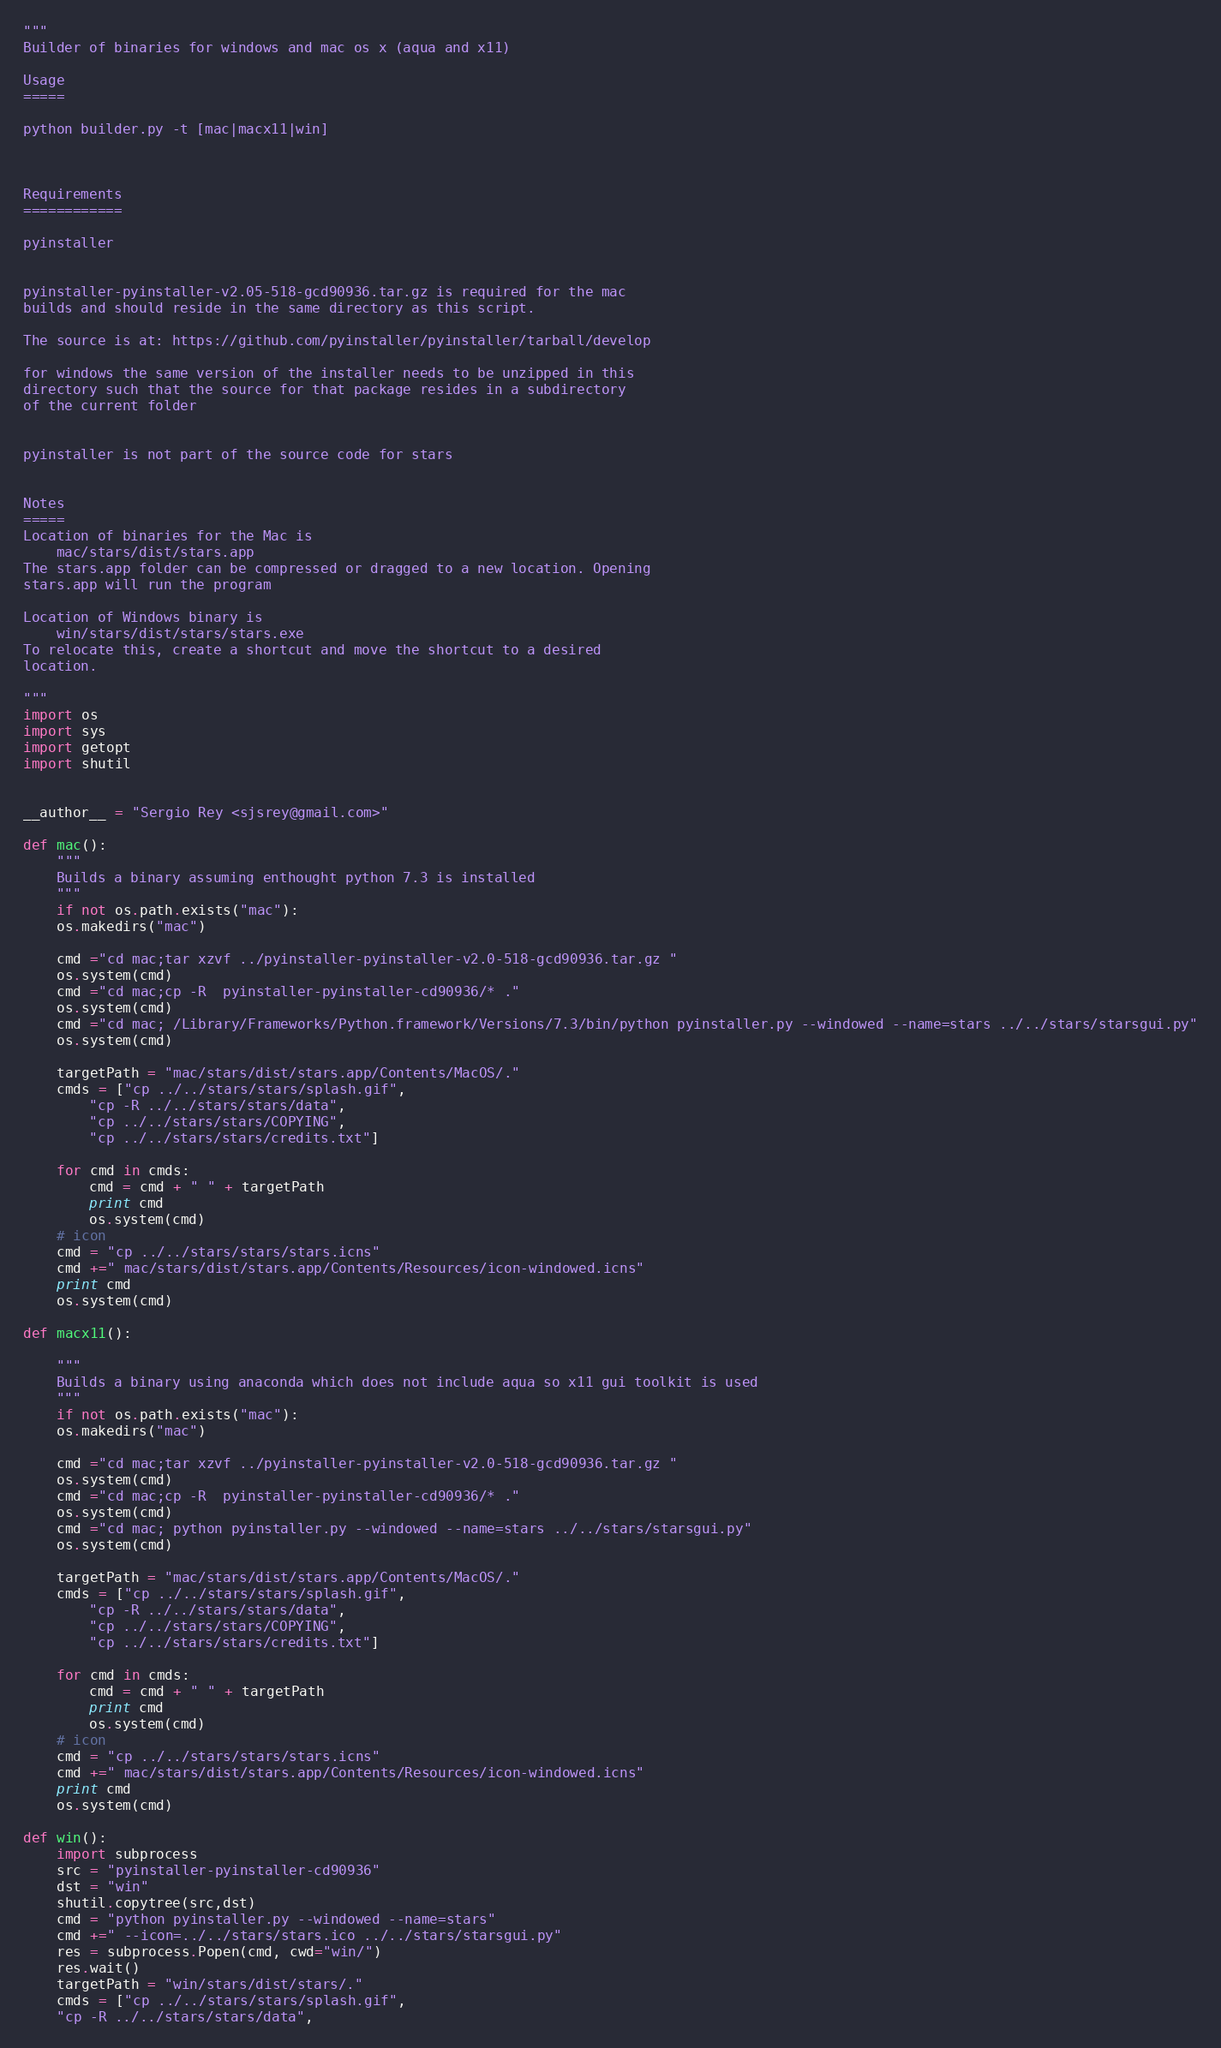<code> <loc_0><loc_0><loc_500><loc_500><_Python_>"""
Builder of binaries for windows and mac os x (aqua and x11)

Usage
=====

python builder.py -t [mac|macx11|win]



Requirements
============

pyinstaller


pyinstaller-pyinstaller-v2.05-518-gcd90936.tar.gz is required for the mac
builds and should reside in the same directory as this script.

The source is at: https://github.com/pyinstaller/pyinstaller/tarball/develop

for windows the same version of the installer needs to be unzipped in this
directory such that the source for that package resides in a subdirectory
of the current folder


pyinstaller is not part of the source code for stars


Notes
=====
Location of binaries for the Mac is 
    mac/stars/dist/stars.app
The stars.app folder can be compressed or dragged to a new location. Opening
stars.app will run the program

Location of Windows binary is
    win/stars/dist/stars/stars.exe
To relocate this, create a shortcut and move the shortcut to a desired
location.

"""
import os
import sys
import getopt
import shutil


__author__ = "Sergio Rey <sjsrey@gmail.com>"

def mac():
    """
    Builds a binary assuming enthought python 7.3 is installed
    """
    if not os.path.exists("mac"):
	os.makedirs("mac")

	cmd ="cd mac;tar xzvf ../pyinstaller-pyinstaller-v2.0-518-gcd90936.tar.gz "
	os.system(cmd)
	cmd ="cd mac;cp -R  pyinstaller-pyinstaller-cd90936/* ."
	os.system(cmd)
	cmd ="cd mac; /Library/Frameworks/Python.framework/Versions/7.3/bin/python pyinstaller.py --windowed --name=stars ../../stars/starsgui.py"
	os.system(cmd)

	targetPath = "mac/stars/dist/stars.app/Contents/MacOS/."
	cmds = ["cp ../../stars/stars/splash.gif",
		"cp -R ../../stars/stars/data",
		"cp ../../stars/stars/COPYING",
		"cp ../../stars/stars/credits.txt"]

	for cmd in cmds:
	    cmd = cmd + " " + targetPath
	    print cmd
	    os.system(cmd)
    # icon
    cmd = "cp ../../stars/stars/stars.icns"
    cmd +=" mac/stars/dist/stars.app/Contents/Resources/icon-windowed.icns"
    print cmd
    os.system(cmd)

def macx11():

    """
    Builds a binary using anaconda which does not include aqua so x11 gui toolkit is used
    """
    if not os.path.exists("mac"):
	os.makedirs("mac")

	cmd ="cd mac;tar xzvf ../pyinstaller-pyinstaller-v2.0-518-gcd90936.tar.gz "
	os.system(cmd)
	cmd ="cd mac;cp -R  pyinstaller-pyinstaller-cd90936/* ."
	os.system(cmd)
	cmd ="cd mac; python pyinstaller.py --windowed --name=stars ../../stars/starsgui.py"
	os.system(cmd)

	targetPath = "mac/stars/dist/stars.app/Contents/MacOS/."
	cmds = ["cp ../../stars/stars/splash.gif",
		"cp -R ../../stars/stars/data",
		"cp ../../stars/stars/COPYING",
		"cp ../../stars/stars/credits.txt"]

	for cmd in cmds:
	    cmd = cmd + " " + targetPath
	    print cmd
	    os.system(cmd)
    # icon
    cmd = "cp ../../stars/stars/stars.icns"
    cmd +=" mac/stars/dist/stars.app/Contents/Resources/icon-windowed.icns"
    print cmd
    os.system(cmd)

def win():
    import subprocess
    src = "pyinstaller-pyinstaller-cd90936"
    dst = "win"
    shutil.copytree(src,dst)
    cmd = "python pyinstaller.py --windowed --name=stars"
    cmd +=" --icon=../../stars/stars.ico ../../stars/starsgui.py"
    res = subprocess.Popen(cmd, cwd="win/")
    res.wait()
    targetPath = "win/stars/dist/stars/."
    cmds = ["cp ../../stars/stars/splash.gif",
	"cp -R ../../stars/stars/data",</code> 